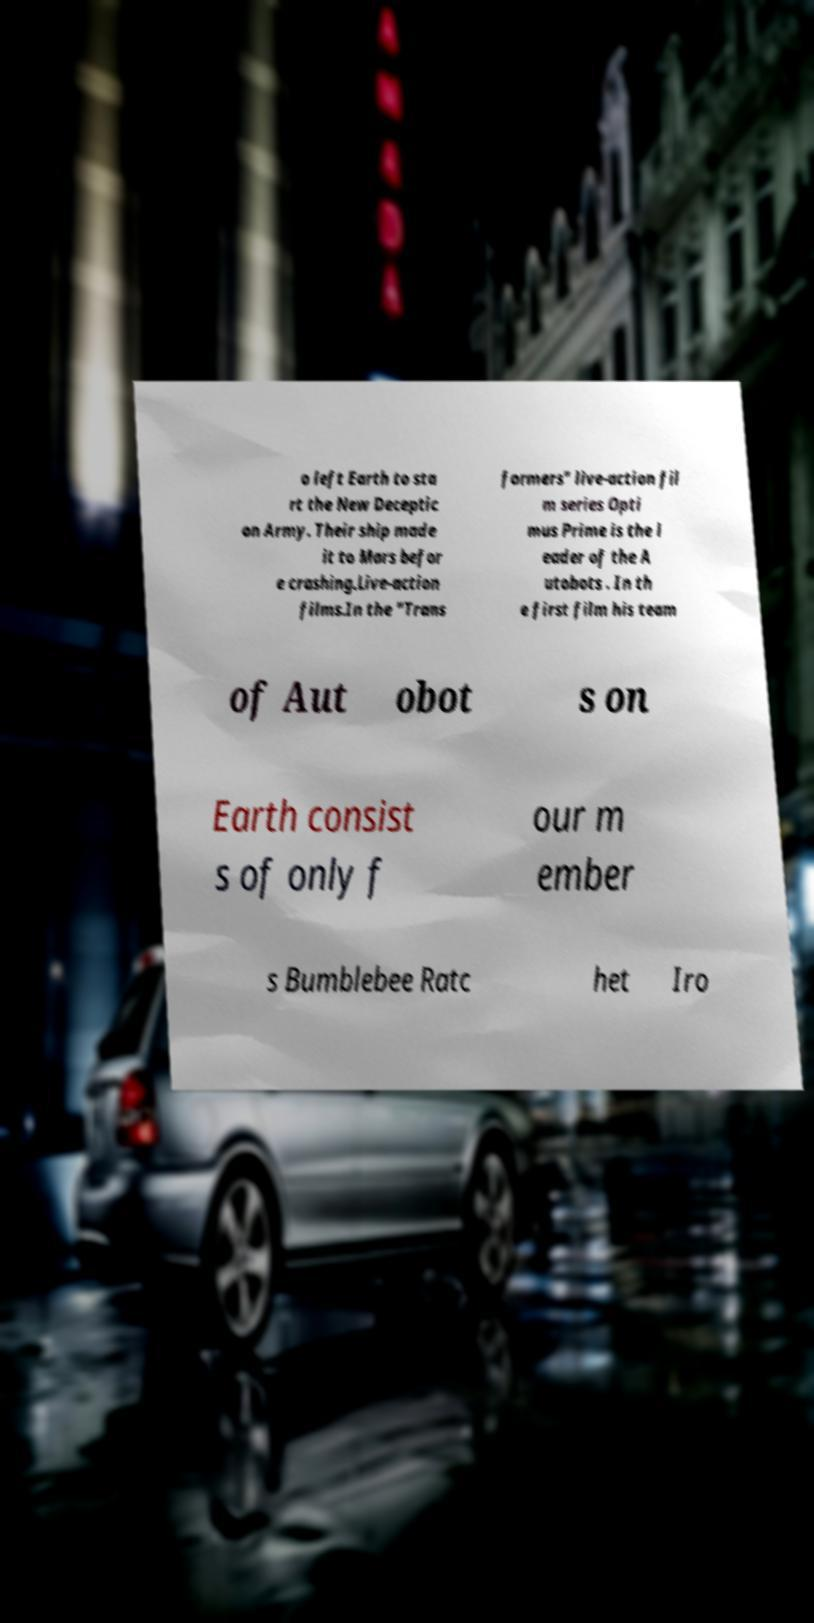Could you assist in decoding the text presented in this image and type it out clearly? o left Earth to sta rt the New Deceptic on Army. Their ship made it to Mars befor e crashing.Live-action films.In the "Trans formers" live-action fil m series Opti mus Prime is the l eader of the A utobots . In th e first film his team of Aut obot s on Earth consist s of only f our m ember s Bumblebee Ratc het Iro 